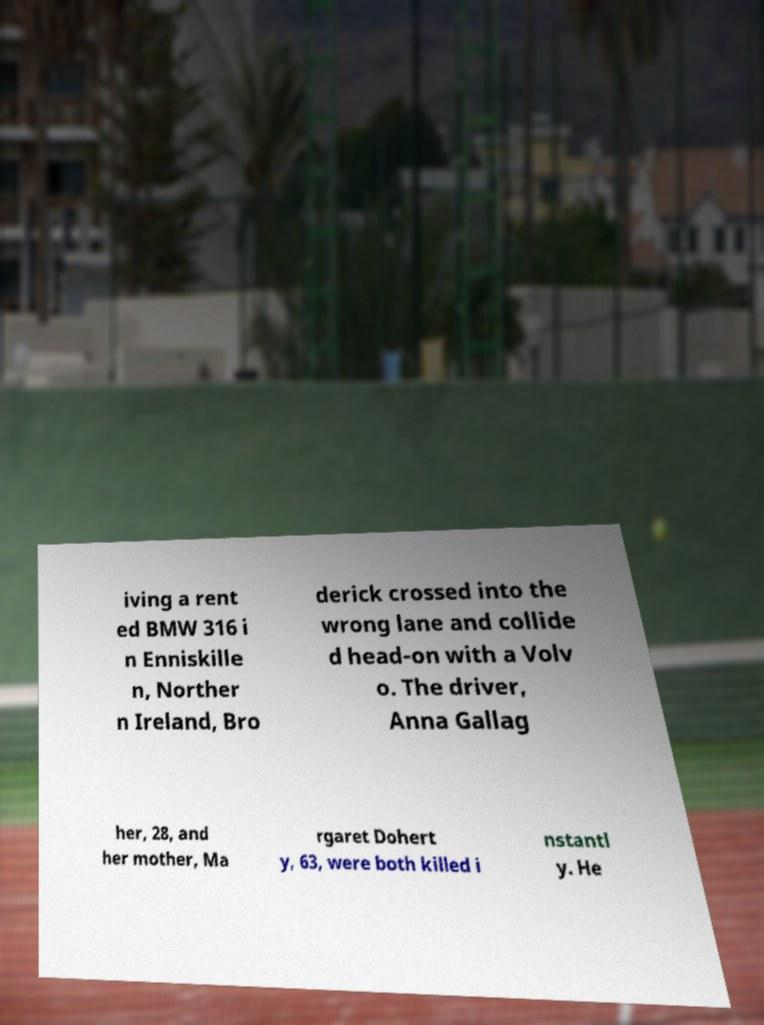Could you assist in decoding the text presented in this image and type it out clearly? iving a rent ed BMW 316 i n Enniskille n, Norther n Ireland, Bro derick crossed into the wrong lane and collide d head-on with a Volv o. The driver, Anna Gallag her, 28, and her mother, Ma rgaret Dohert y, 63, were both killed i nstantl y. He 